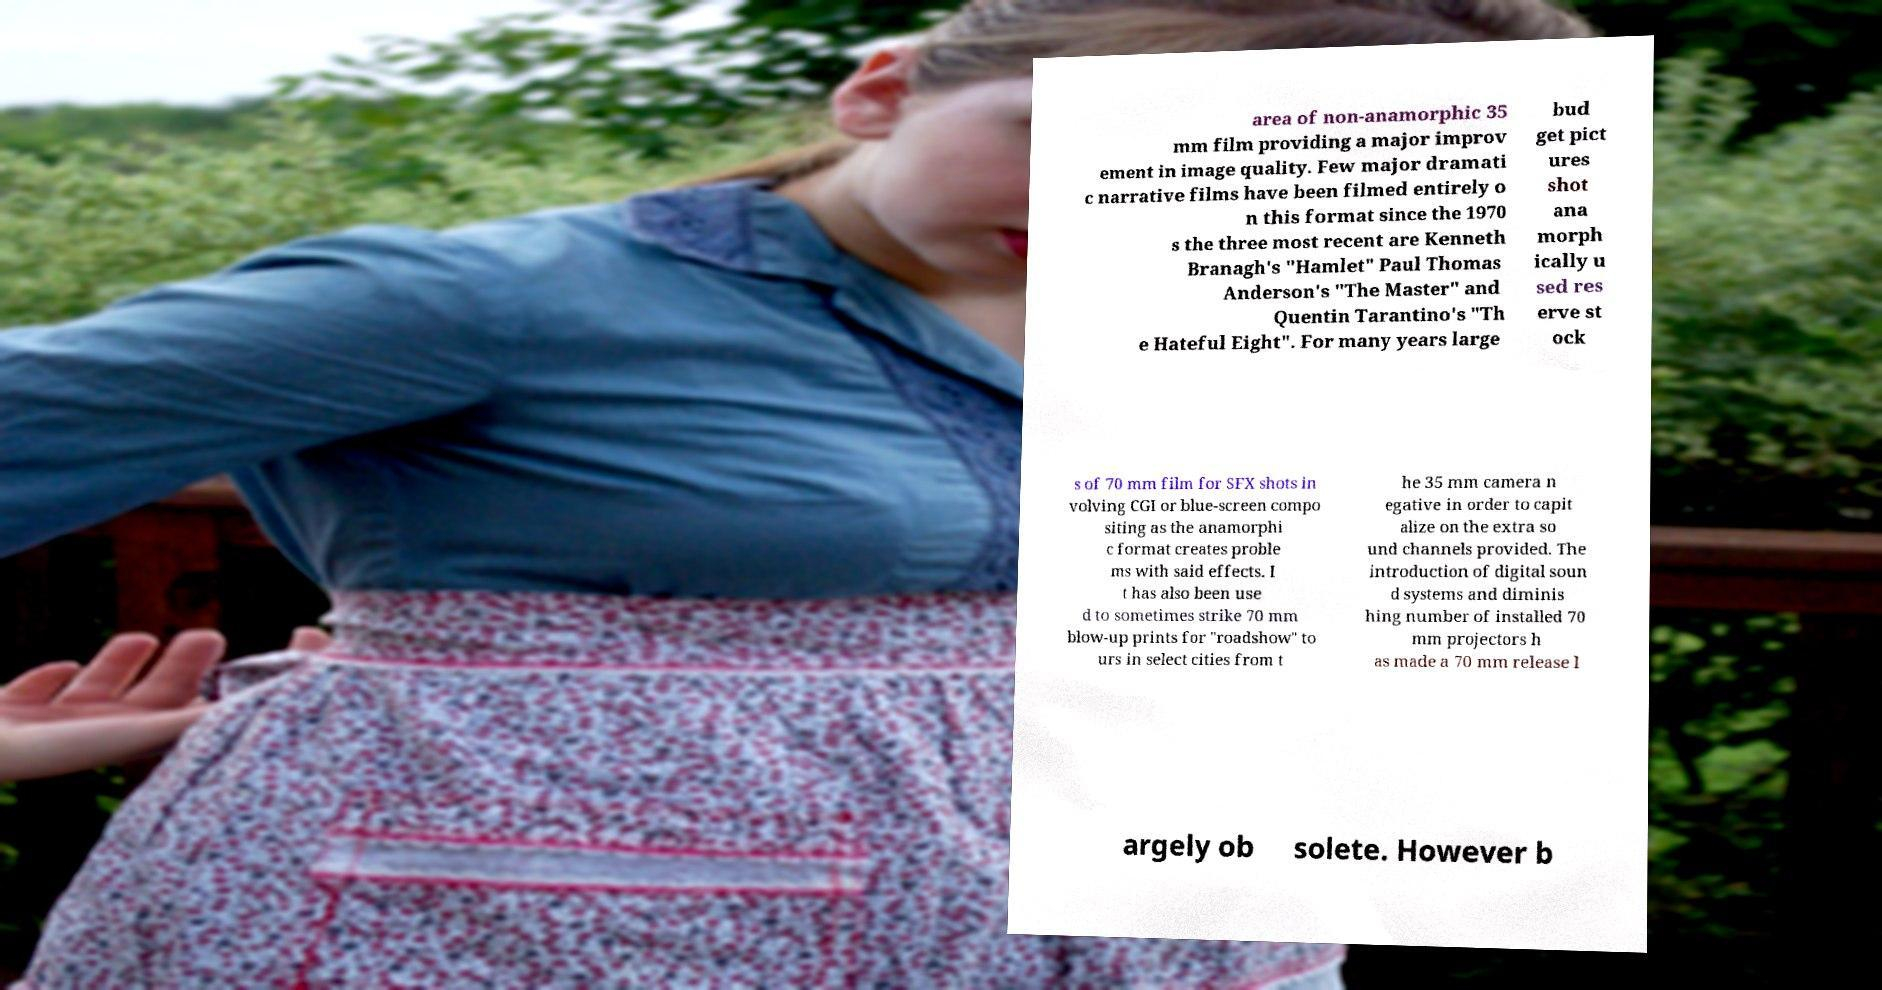What messages or text are displayed in this image? I need them in a readable, typed format. area of non-anamorphic 35 mm film providing a major improv ement in image quality. Few major dramati c narrative films have been filmed entirely o n this format since the 1970 s the three most recent are Kenneth Branagh's "Hamlet" Paul Thomas Anderson's "The Master" and Quentin Tarantino's "Th e Hateful Eight". For many years large bud get pict ures shot ana morph ically u sed res erve st ock s of 70 mm film for SFX shots in volving CGI or blue-screen compo siting as the anamorphi c format creates proble ms with said effects. I t has also been use d to sometimes strike 70 mm blow-up prints for "roadshow" to urs in select cities from t he 35 mm camera n egative in order to capit alize on the extra so und channels provided. The introduction of digital soun d systems and diminis hing number of installed 70 mm projectors h as made a 70 mm release l argely ob solete. However b 